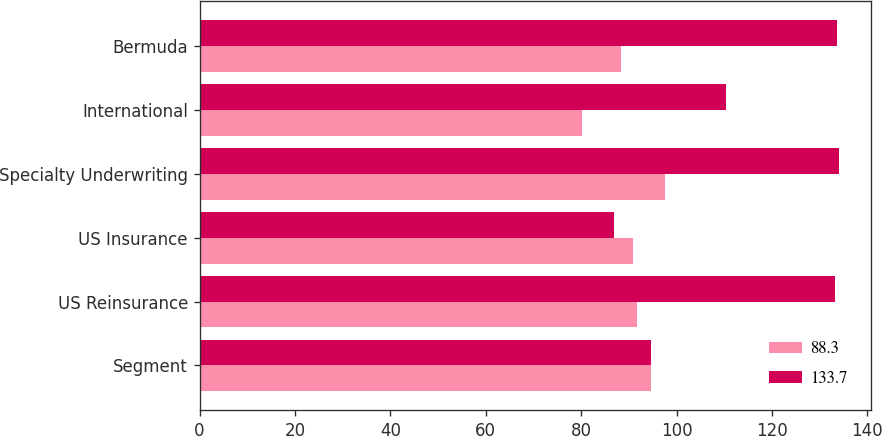Convert chart. <chart><loc_0><loc_0><loc_500><loc_500><stacked_bar_chart><ecel><fcel>Segment<fcel>US Reinsurance<fcel>US Insurance<fcel>Specialty Underwriting<fcel>International<fcel>Bermuda<nl><fcel>88.3<fcel>94.6<fcel>91.7<fcel>90.8<fcel>97.5<fcel>80.2<fcel>88.3<nl><fcel>133.7<fcel>94.6<fcel>133.3<fcel>86.9<fcel>134.1<fcel>110.4<fcel>133.7<nl></chart> 